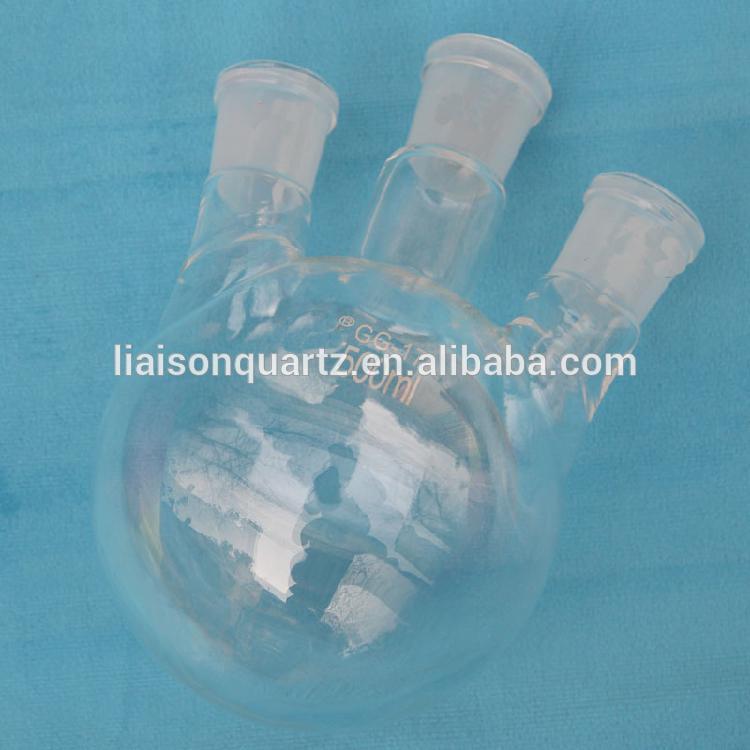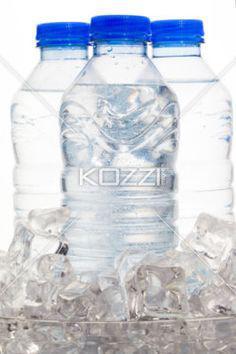The first image is the image on the left, the second image is the image on the right. Analyze the images presented: Is the assertion "At least three of the bottles in one of the images has a blue cap." valid? Answer yes or no. Yes. The first image is the image on the left, the second image is the image on the right. For the images displayed, is the sentence "An image shows multiple water bottles surrounded by ice cubes." factually correct? Answer yes or no. Yes. 